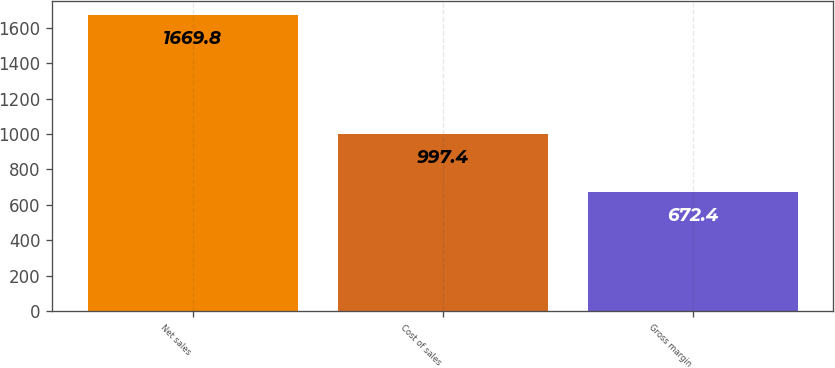Convert chart. <chart><loc_0><loc_0><loc_500><loc_500><bar_chart><fcel>Net sales<fcel>Cost of sales<fcel>Gross margin<nl><fcel>1669.8<fcel>997.4<fcel>672.4<nl></chart> 